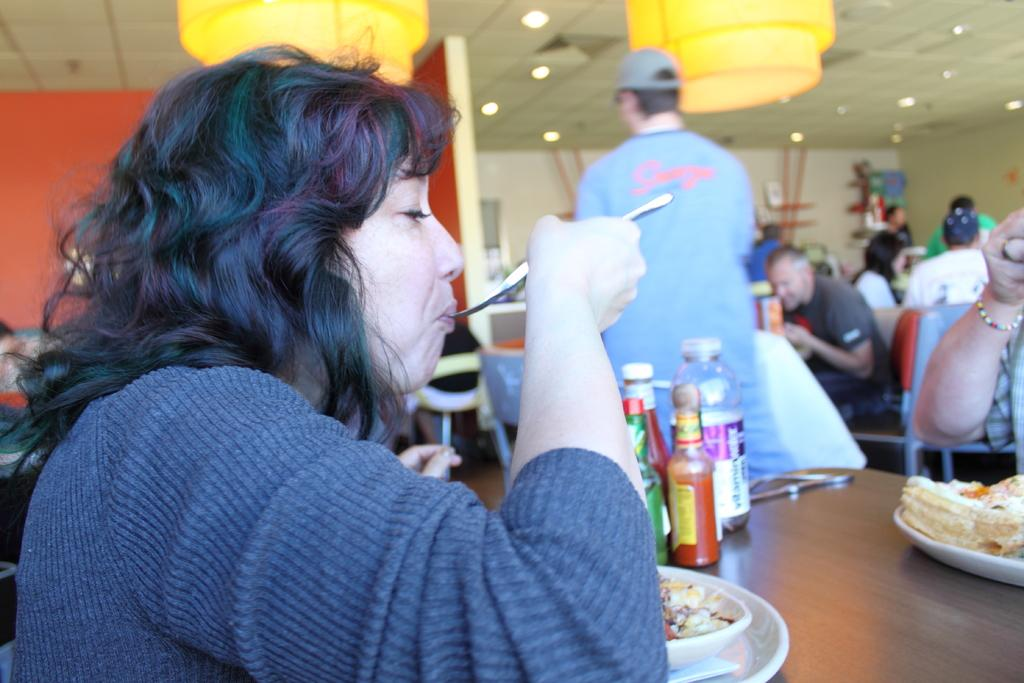What are the people in the image doing? The people in the image are sitting in front of tables and eating. Can you describe the position of the person standing in the image? There is a person standing on the side in the image. What type of brush is the beggar using to groom the beast in the image? There is no beggar or beast present in the image, and therefore no such activity can be observed. 